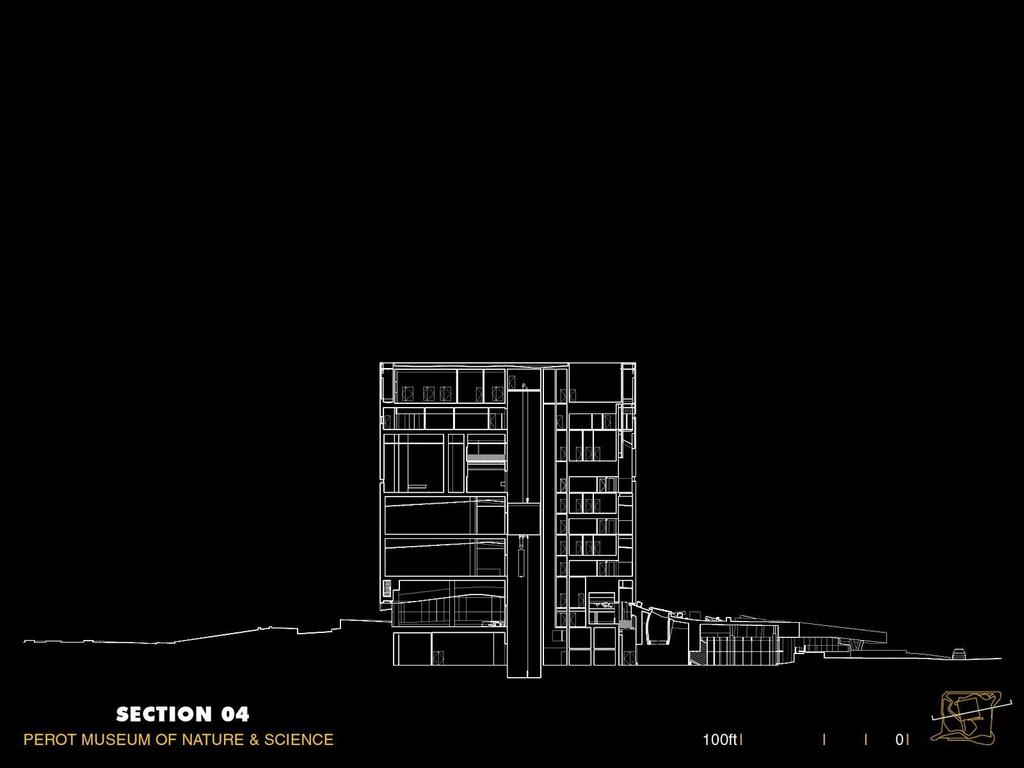What is the main subject of the image? The main subject of the image is a sketch of a building. What else can be seen in the image besides the sketch? There is text and numbers in the image. What color is the background of the image? The background of the image is black. What is the creator's wealth based on the image? There is no information about the creator's wealth in the image. 